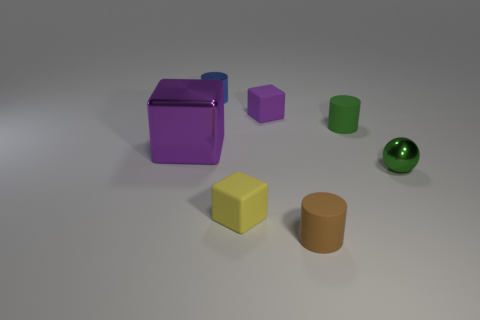Subtract all small blue cylinders. How many cylinders are left? 2 How many purple blocks must be subtracted to get 1 purple blocks? 1 Subtract all yellow cubes. How many cubes are left? 2 Subtract 2 blocks. How many blocks are left? 1 Subtract all blue cylinders. Subtract all red spheres. How many cylinders are left? 2 Subtract all brown cylinders. How many brown blocks are left? 0 Subtract all gray shiny cylinders. Subtract all tiny spheres. How many objects are left? 6 Add 3 large cubes. How many large cubes are left? 4 Add 7 cylinders. How many cylinders exist? 10 Add 1 purple matte blocks. How many objects exist? 8 